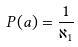<formula> <loc_0><loc_0><loc_500><loc_500>P ( a ) = \frac { 1 } { \aleph _ { 1 } }</formula> 